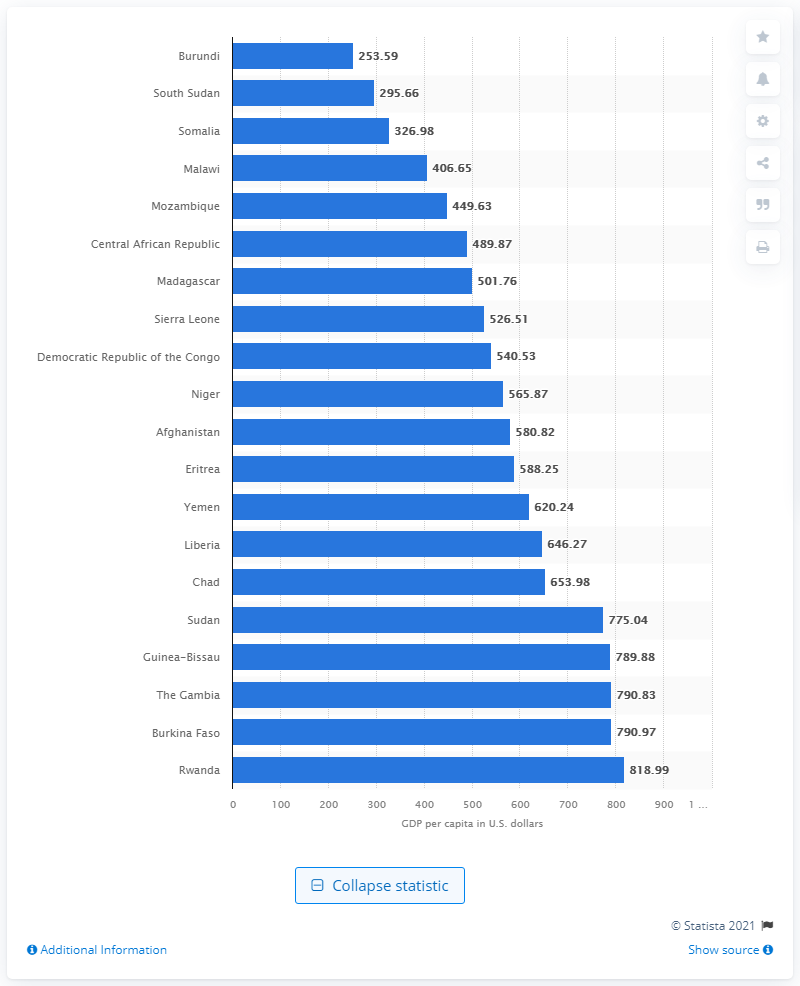Draw attention to some important aspects in this diagram. Burundi had the lowest per-capita GDP of any country in recorded history. 